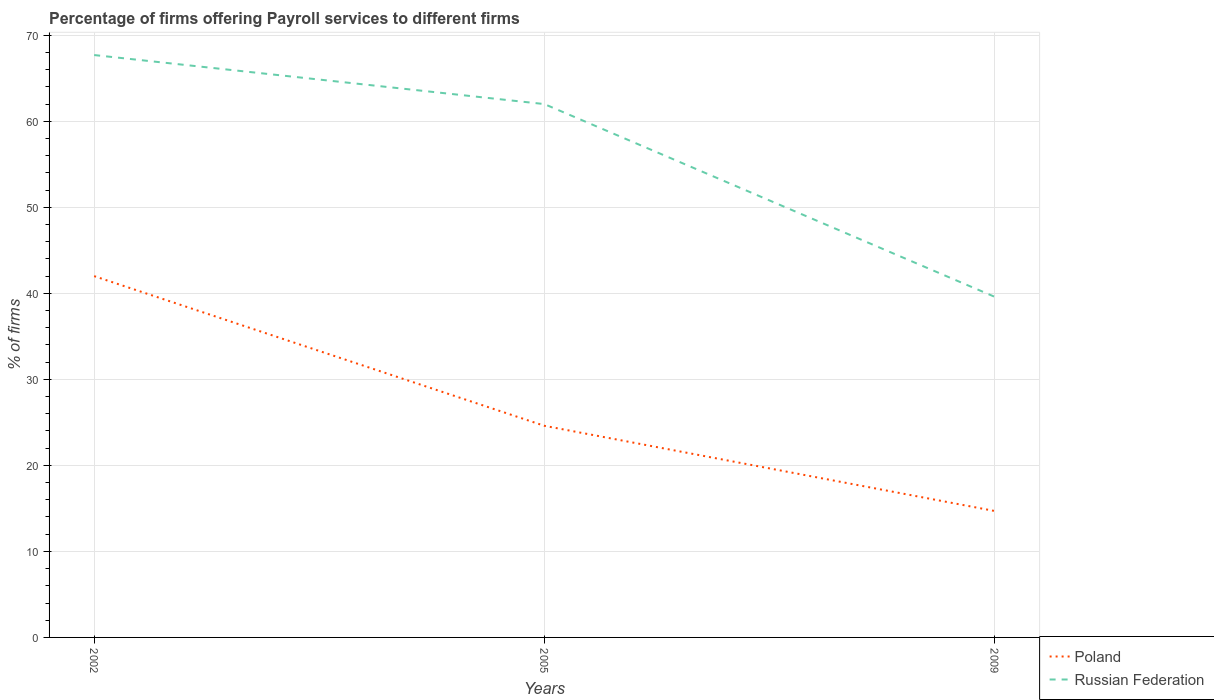How many different coloured lines are there?
Your answer should be compact. 2. Does the line corresponding to Russian Federation intersect with the line corresponding to Poland?
Keep it short and to the point. No. Is the number of lines equal to the number of legend labels?
Ensure brevity in your answer.  Yes. Across all years, what is the maximum percentage of firms offering payroll services in Russian Federation?
Your response must be concise. 39.6. In which year was the percentage of firms offering payroll services in Poland maximum?
Keep it short and to the point. 2009. What is the total percentage of firms offering payroll services in Poland in the graph?
Provide a short and direct response. 27.3. What is the difference between the highest and the second highest percentage of firms offering payroll services in Russian Federation?
Ensure brevity in your answer.  28.1. How many lines are there?
Your response must be concise. 2. How many years are there in the graph?
Provide a succinct answer. 3. Does the graph contain any zero values?
Provide a short and direct response. No. How many legend labels are there?
Your answer should be compact. 2. How are the legend labels stacked?
Your answer should be very brief. Vertical. What is the title of the graph?
Your answer should be very brief. Percentage of firms offering Payroll services to different firms. What is the label or title of the X-axis?
Give a very brief answer. Years. What is the label or title of the Y-axis?
Your response must be concise. % of firms. What is the % of firms of Russian Federation in 2002?
Your answer should be very brief. 67.7. What is the % of firms in Poland in 2005?
Provide a short and direct response. 24.6. What is the % of firms in Poland in 2009?
Offer a terse response. 14.7. What is the % of firms of Russian Federation in 2009?
Ensure brevity in your answer.  39.6. Across all years, what is the maximum % of firms in Russian Federation?
Give a very brief answer. 67.7. Across all years, what is the minimum % of firms in Russian Federation?
Your answer should be very brief. 39.6. What is the total % of firms of Poland in the graph?
Offer a terse response. 81.3. What is the total % of firms in Russian Federation in the graph?
Provide a short and direct response. 169.3. What is the difference between the % of firms in Poland in 2002 and that in 2005?
Provide a succinct answer. 17.4. What is the difference between the % of firms in Russian Federation in 2002 and that in 2005?
Give a very brief answer. 5.7. What is the difference between the % of firms in Poland in 2002 and that in 2009?
Ensure brevity in your answer.  27.3. What is the difference between the % of firms in Russian Federation in 2002 and that in 2009?
Your answer should be very brief. 28.1. What is the difference between the % of firms in Poland in 2005 and that in 2009?
Offer a terse response. 9.9. What is the difference between the % of firms in Russian Federation in 2005 and that in 2009?
Offer a very short reply. 22.4. What is the difference between the % of firms in Poland in 2002 and the % of firms in Russian Federation in 2005?
Offer a very short reply. -20. What is the difference between the % of firms of Poland in 2002 and the % of firms of Russian Federation in 2009?
Offer a terse response. 2.4. What is the difference between the % of firms of Poland in 2005 and the % of firms of Russian Federation in 2009?
Provide a short and direct response. -15. What is the average % of firms of Poland per year?
Your answer should be compact. 27.1. What is the average % of firms of Russian Federation per year?
Provide a succinct answer. 56.43. In the year 2002, what is the difference between the % of firms of Poland and % of firms of Russian Federation?
Keep it short and to the point. -25.7. In the year 2005, what is the difference between the % of firms of Poland and % of firms of Russian Federation?
Provide a succinct answer. -37.4. In the year 2009, what is the difference between the % of firms in Poland and % of firms in Russian Federation?
Make the answer very short. -24.9. What is the ratio of the % of firms of Poland in 2002 to that in 2005?
Your response must be concise. 1.71. What is the ratio of the % of firms in Russian Federation in 2002 to that in 2005?
Provide a succinct answer. 1.09. What is the ratio of the % of firms in Poland in 2002 to that in 2009?
Provide a succinct answer. 2.86. What is the ratio of the % of firms in Russian Federation in 2002 to that in 2009?
Give a very brief answer. 1.71. What is the ratio of the % of firms in Poland in 2005 to that in 2009?
Make the answer very short. 1.67. What is the ratio of the % of firms in Russian Federation in 2005 to that in 2009?
Your answer should be very brief. 1.57. What is the difference between the highest and the second highest % of firms of Poland?
Provide a short and direct response. 17.4. What is the difference between the highest and the lowest % of firms in Poland?
Ensure brevity in your answer.  27.3. What is the difference between the highest and the lowest % of firms in Russian Federation?
Provide a short and direct response. 28.1. 